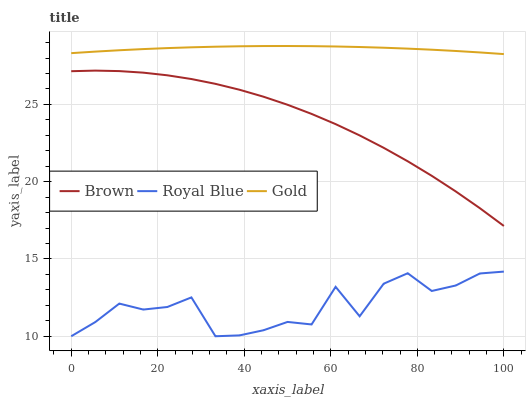Does Royal Blue have the minimum area under the curve?
Answer yes or no. Yes. Does Gold have the maximum area under the curve?
Answer yes or no. Yes. Does Gold have the minimum area under the curve?
Answer yes or no. No. Does Royal Blue have the maximum area under the curve?
Answer yes or no. No. Is Gold the smoothest?
Answer yes or no. Yes. Is Royal Blue the roughest?
Answer yes or no. Yes. Is Royal Blue the smoothest?
Answer yes or no. No. Is Gold the roughest?
Answer yes or no. No. Does Gold have the lowest value?
Answer yes or no. No. Does Royal Blue have the highest value?
Answer yes or no. No. Is Brown less than Gold?
Answer yes or no. Yes. Is Gold greater than Brown?
Answer yes or no. Yes. Does Brown intersect Gold?
Answer yes or no. No. 